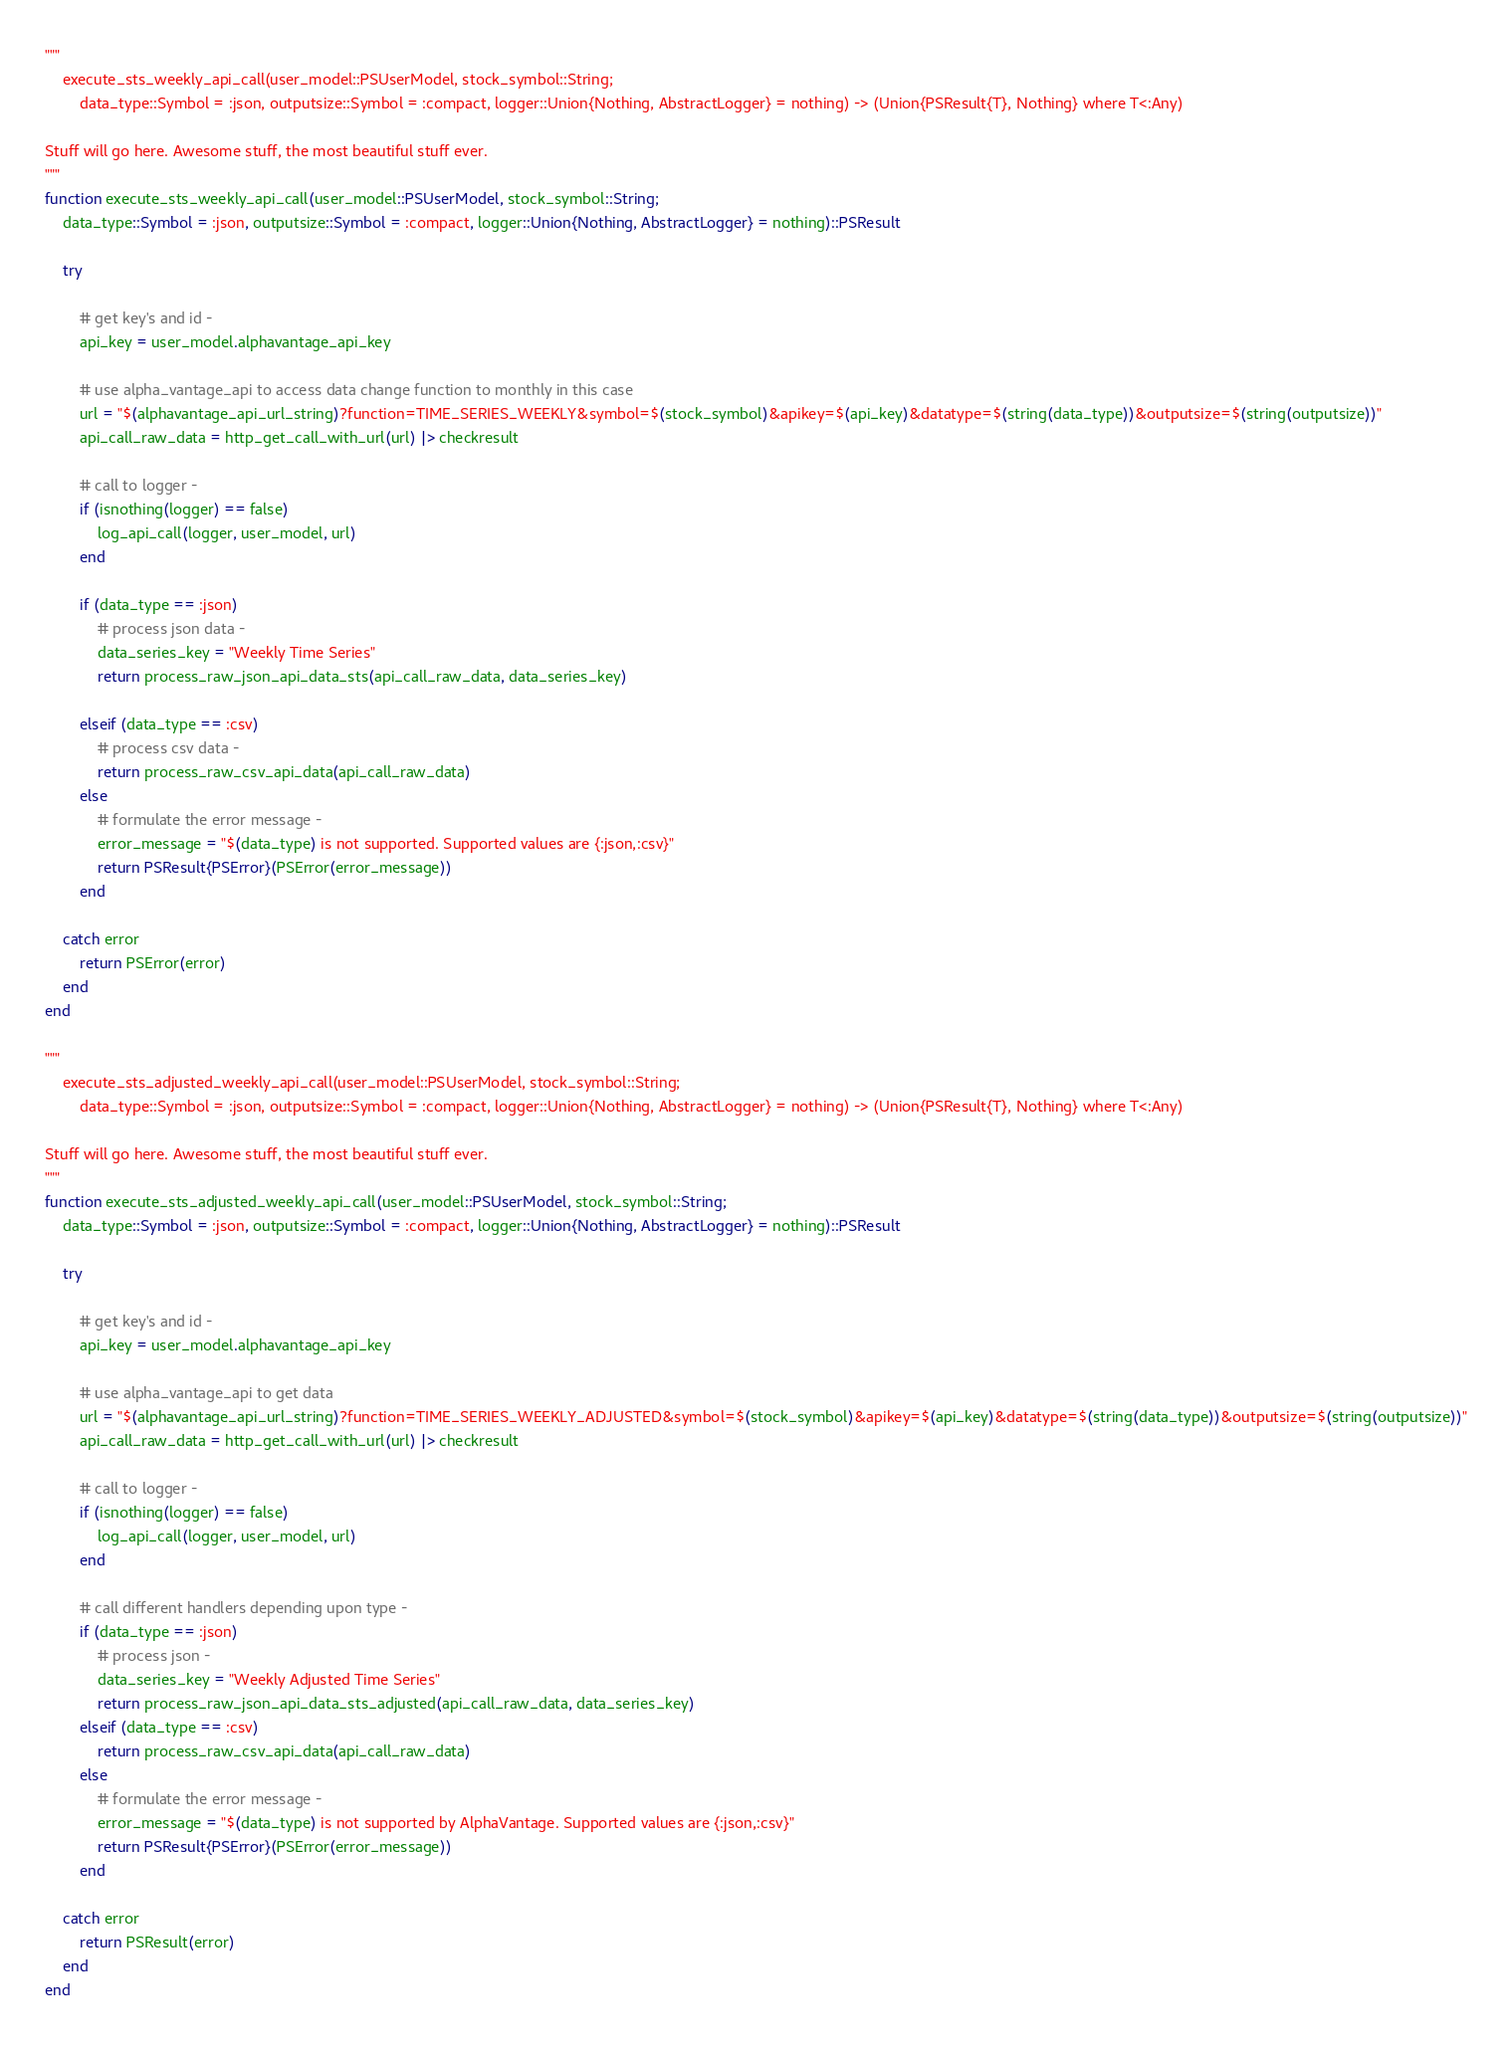Convert code to text. <code><loc_0><loc_0><loc_500><loc_500><_Julia_>"""
    execute_sts_weekly_api_call(user_model::PSUserModel, stock_symbol::String; 
        data_type::Symbol = :json, outputsize::Symbol = :compact, logger::Union{Nothing, AbstractLogger} = nothing) -> (Union{PSResult{T}, Nothing} where T<:Any)

Stuff will go here. Awesome stuff, the most beautiful stuff ever.
"""
function execute_sts_weekly_api_call(user_model::PSUserModel, stock_symbol::String; 
    data_type::Symbol = :json, outputsize::Symbol = :compact, logger::Union{Nothing, AbstractLogger} = nothing)::PSResult

    try 
        
        # get key's and id -
        api_key = user_model.alphavantage_api_key

        # use alpha_vantage_api to access data change function to monthly in this case
        url = "$(alphavantage_api_url_string)?function=TIME_SERIES_WEEKLY&symbol=$(stock_symbol)&apikey=$(api_key)&datatype=$(string(data_type))&outputsize=$(string(outputsize))"
        api_call_raw_data = http_get_call_with_url(url) |> checkresult
    
        # call to logger -
        if (isnothing(logger) == false)
            log_api_call(logger, user_model, url)
        end

        if (data_type == :json)
            # process json data -
            data_series_key = "Weekly Time Series"
            return process_raw_json_api_data_sts(api_call_raw_data, data_series_key)
    
        elseif (data_type == :csv)
            # process csv data -
            return process_raw_csv_api_data(api_call_raw_data)
        else
            # formulate the error message -
            error_message = "$(data_type) is not supported. Supported values are {:json,:csv}"
            return PSResult{PSError}(PSError(error_message))
        end

    catch error
        return PSError(error)
    end
end

"""
    execute_sts_adjusted_weekly_api_call(user_model::PSUserModel, stock_symbol::String; 
        data_type::Symbol = :json, outputsize::Symbol = :compact, logger::Union{Nothing, AbstractLogger} = nothing) -> (Union{PSResult{T}, Nothing} where T<:Any)

Stuff will go here. Awesome stuff, the most beautiful stuff ever.
"""
function execute_sts_adjusted_weekly_api_call(user_model::PSUserModel, stock_symbol::String; 
    data_type::Symbol = :json, outputsize::Symbol = :compact, logger::Union{Nothing, AbstractLogger} = nothing)::PSResult
    
    try

        # get key's and id -
        api_key = user_model.alphavantage_api_key

        # use alpha_vantage_api to get data
        url = "$(alphavantage_api_url_string)?function=TIME_SERIES_WEEKLY_ADJUSTED&symbol=$(stock_symbol)&apikey=$(api_key)&datatype=$(string(data_type))&outputsize=$(string(outputsize))"
        api_call_raw_data = http_get_call_with_url(url) |> checkresult
    
        # call to logger -
        if (isnothing(logger) == false)
            log_api_call(logger, user_model, url)
        end

        # call different handlers depending upon type -
        if (data_type == :json)
            # process json -
            data_series_key = "Weekly Adjusted Time Series"
            return process_raw_json_api_data_sts_adjusted(api_call_raw_data, data_series_key)
        elseif (data_type == :csv)
            return process_raw_csv_api_data(api_call_raw_data)
        else
            # formulate the error message -
            error_message = "$(data_type) is not supported by AlphaVantage. Supported values are {:json,:csv}"
            return PSResult{PSError}(PSError(error_message))
        end

    catch error
        return PSResult(error)
    end
end
</code> 